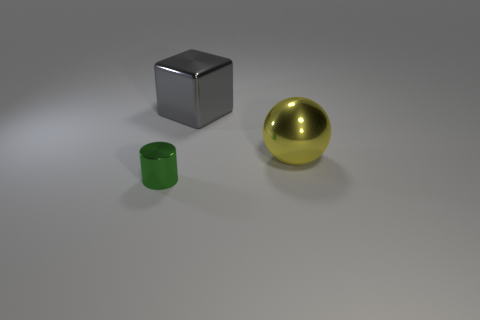What color is the large sphere that is made of the same material as the small thing?
Your response must be concise. Yellow. Does the large block have the same material as the thing in front of the big ball?
Provide a short and direct response. Yes. What is the color of the shiny object that is behind the shiny cylinder and in front of the metallic block?
Provide a succinct answer. Yellow. What number of balls are small brown rubber things or gray shiny objects?
Give a very brief answer. 0. Do the green thing and the large object behind the yellow ball have the same shape?
Offer a terse response. No. What size is the metal thing that is in front of the large gray metal thing and behind the small green shiny cylinder?
Offer a very short reply. Large. What shape is the green thing?
Offer a terse response. Cylinder. Is there a big yellow metal object that is on the left side of the thing behind the yellow shiny ball?
Ensure brevity in your answer.  No. What number of gray blocks are right of the large metal object that is on the right side of the large gray shiny block?
Your response must be concise. 0. What material is the object that is the same size as the gray cube?
Your answer should be compact. Metal. 